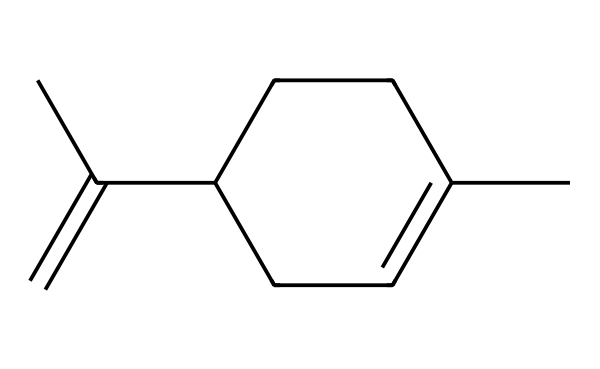What is the name of this chemical? This chemical has the SMILES representation that corresponds to limonene, which is a prominent compound responsible for citrus scents in perfumes.
Answer: limonene How many carbon atoms are in this molecule? By analyzing the structure represented in the SMILES, we count a total of 10 carbon atoms connected in the various rings and chains.
Answer: 10 What type of chemical structure is limonene? Limonene consists of a cyclic structure with a double bond, categorizing it as a terpene, which is commonly found in plant essential oils.
Answer: terpene What functional group is present in limonene? The structure contains a double bond (indicated in the SMILES by "=C"), identifying the presence of an alkene functional group within the chemical.
Answer: alkene Is limonene chiral? Looking at the structure, we can see that there are carbons with four different substituents, indicating that limonene has a chiral center.
Answer: yes What scent does limonene contribute to perfumes? The unique structure of limonene, especially its carbon arrangement, generates a fresh, citrusy aroma, making it a popular choice in high-end fragrances.
Answer: citrus 